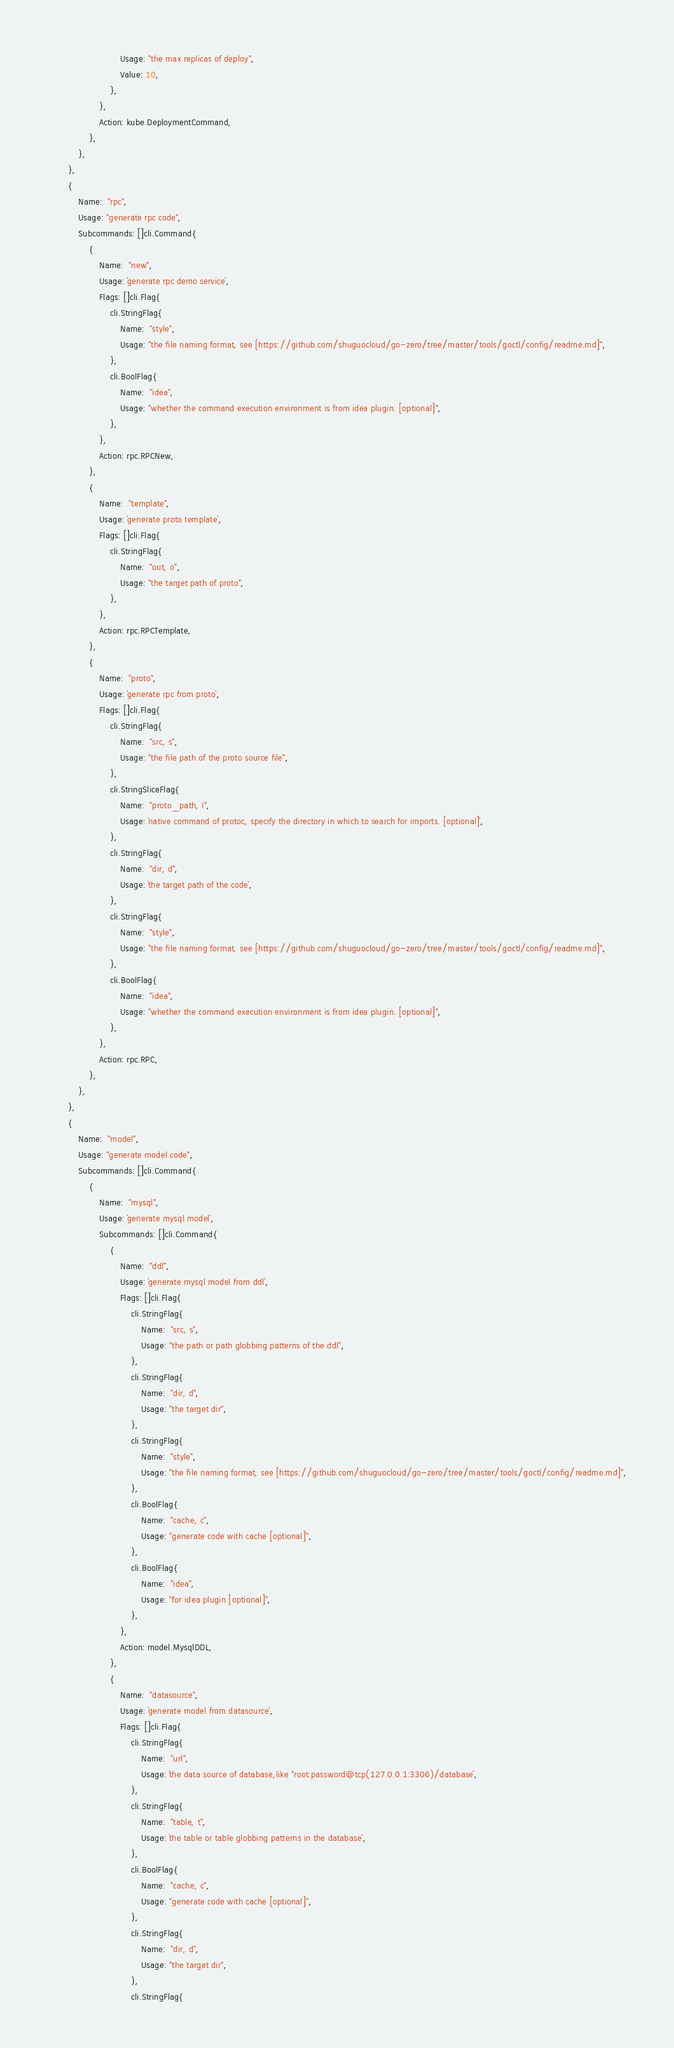<code> <loc_0><loc_0><loc_500><loc_500><_Go_>							Usage: "the max replicas of deploy",
							Value: 10,
						},
					},
					Action: kube.DeploymentCommand,
				},
			},
		},
		{
			Name:  "rpc",
			Usage: "generate rpc code",
			Subcommands: []cli.Command{
				{
					Name:  "new",
					Usage: `generate rpc demo service`,
					Flags: []cli.Flag{
						cli.StringFlag{
							Name:  "style",
							Usage: "the file naming format, see [https://github.com/shuguocloud/go-zero/tree/master/tools/goctl/config/readme.md]",
						},
						cli.BoolFlag{
							Name:  "idea",
							Usage: "whether the command execution environment is from idea plugin. [optional]",
						},
					},
					Action: rpc.RPCNew,
				},
				{
					Name:  "template",
					Usage: `generate proto template`,
					Flags: []cli.Flag{
						cli.StringFlag{
							Name:  "out, o",
							Usage: "the target path of proto",
						},
					},
					Action: rpc.RPCTemplate,
				},
				{
					Name:  "proto",
					Usage: `generate rpc from proto`,
					Flags: []cli.Flag{
						cli.StringFlag{
							Name:  "src, s",
							Usage: "the file path of the proto source file",
						},
						cli.StringSliceFlag{
							Name:  "proto_path, I",
							Usage: `native command of protoc, specify the directory in which to search for imports. [optional]`,
						},
						cli.StringFlag{
							Name:  "dir, d",
							Usage: `the target path of the code`,
						},
						cli.StringFlag{
							Name:  "style",
							Usage: "the file naming format, see [https://github.com/shuguocloud/go-zero/tree/master/tools/goctl/config/readme.md]",
						},
						cli.BoolFlag{
							Name:  "idea",
							Usage: "whether the command execution environment is from idea plugin. [optional]",
						},
					},
					Action: rpc.RPC,
				},
			},
		},
		{
			Name:  "model",
			Usage: "generate model code",
			Subcommands: []cli.Command{
				{
					Name:  "mysql",
					Usage: `generate mysql model`,
					Subcommands: []cli.Command{
						{
							Name:  "ddl",
							Usage: `generate mysql model from ddl`,
							Flags: []cli.Flag{
								cli.StringFlag{
									Name:  "src, s",
									Usage: "the path or path globbing patterns of the ddl",
								},
								cli.StringFlag{
									Name:  "dir, d",
									Usage: "the target dir",
								},
								cli.StringFlag{
									Name:  "style",
									Usage: "the file naming format, see [https://github.com/shuguocloud/go-zero/tree/master/tools/goctl/config/readme.md]",
								},
								cli.BoolFlag{
									Name:  "cache, c",
									Usage: "generate code with cache [optional]",
								},
								cli.BoolFlag{
									Name:  "idea",
									Usage: "for idea plugin [optional]",
								},
							},
							Action: model.MysqlDDL,
						},
						{
							Name:  "datasource",
							Usage: `generate model from datasource`,
							Flags: []cli.Flag{
								cli.StringFlag{
									Name:  "url",
									Usage: `the data source of database,like "root:password@tcp(127.0.0.1:3306)/database`,
								},
								cli.StringFlag{
									Name:  "table, t",
									Usage: `the table or table globbing patterns in the database`,
								},
								cli.BoolFlag{
									Name:  "cache, c",
									Usage: "generate code with cache [optional]",
								},
								cli.StringFlag{
									Name:  "dir, d",
									Usage: "the target dir",
								},
								cli.StringFlag{</code> 